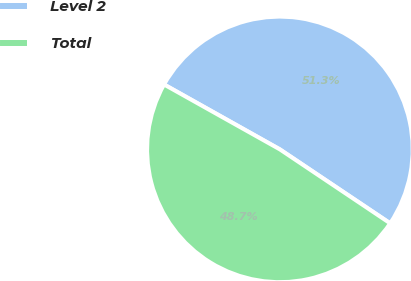<chart> <loc_0><loc_0><loc_500><loc_500><pie_chart><fcel>Level 2<fcel>Total<nl><fcel>51.27%<fcel>48.73%<nl></chart> 